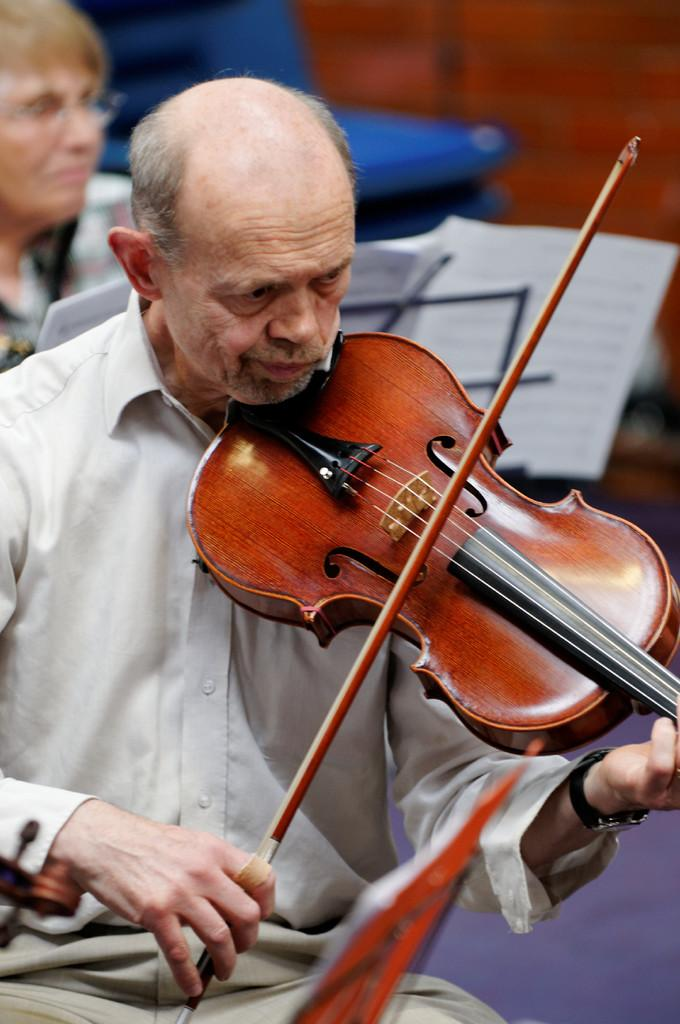What is the person in the image holding along with the guitar? The person is also holding a stick in the image. Can you describe the position of the second person in relation to the first person? The second person is visible behind the first person in the image. What type of furniture can be seen in the image? There is a blue color chair visible in the image. How much money is visible on the floor in the image? There is no money visible on the floor in the image. What type of ring is the person wearing on their finger in the image? There is no ring visible on any person's finger in the image. 